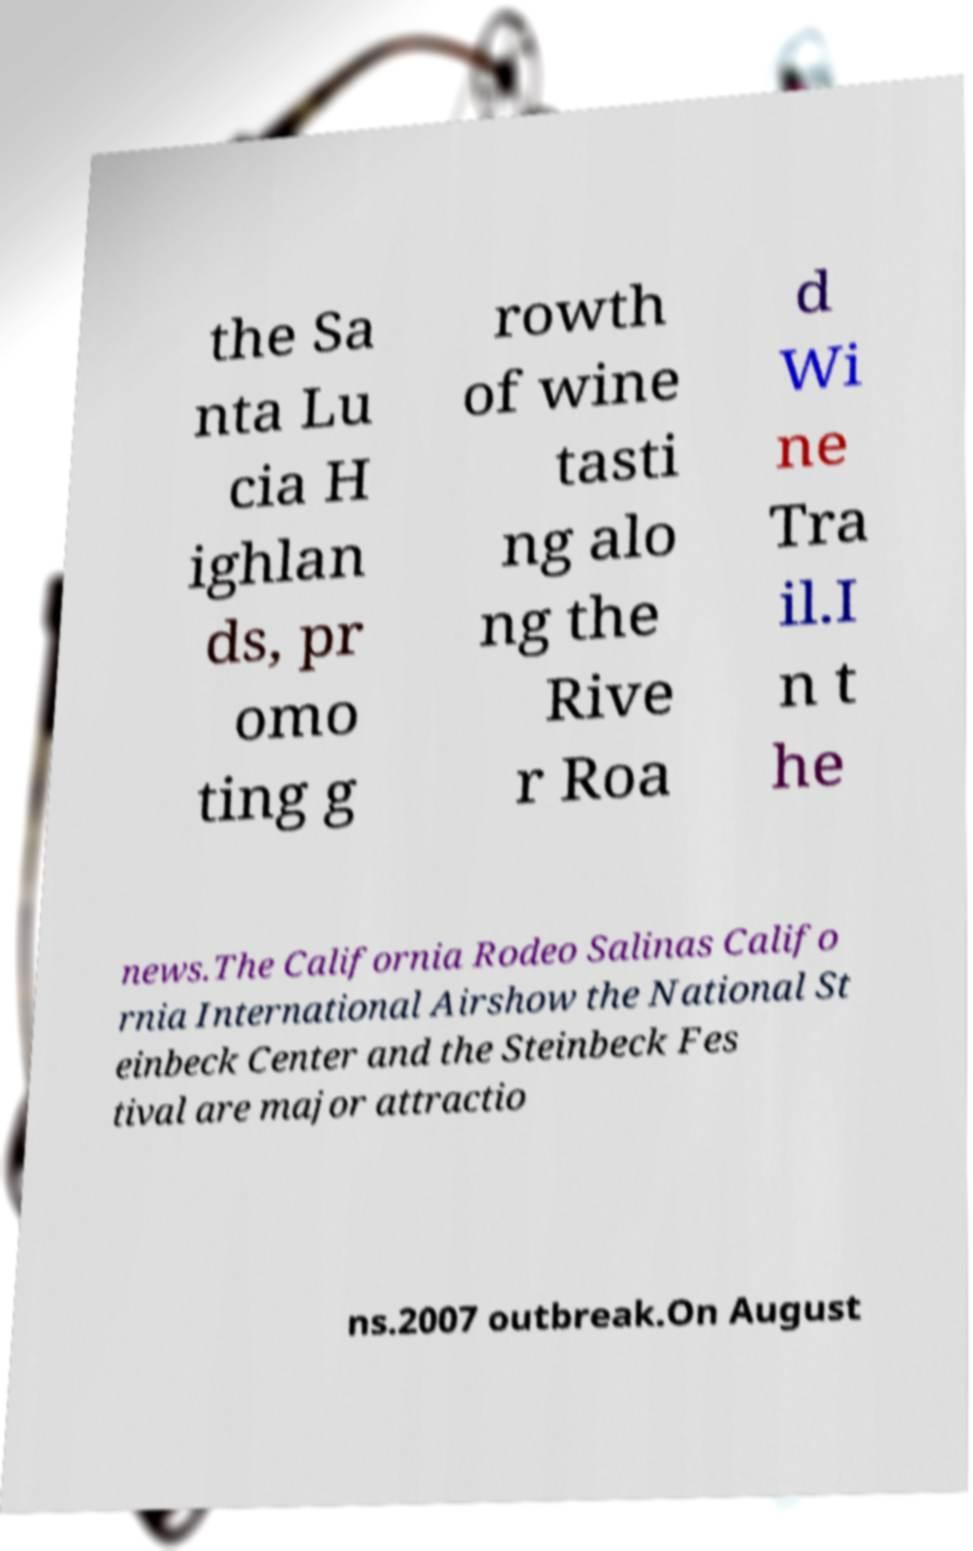Could you extract and type out the text from this image? the Sa nta Lu cia H ighlan ds, pr omo ting g rowth of wine tasti ng alo ng the Rive r Roa d Wi ne Tra il.I n t he news.The California Rodeo Salinas Califo rnia International Airshow the National St einbeck Center and the Steinbeck Fes tival are major attractio ns.2007 outbreak.On August 